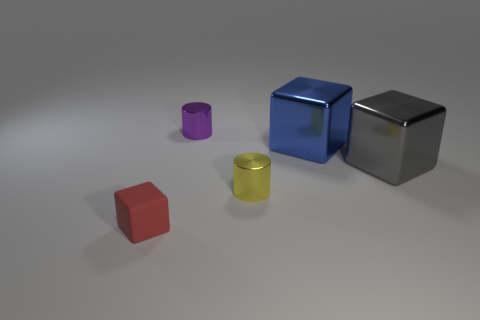Is there anything else that is the same size as the blue thing?
Ensure brevity in your answer.  Yes. What is the shape of the tiny metallic object that is in front of the gray shiny cube?
Provide a short and direct response. Cylinder. What is the color of the other small cylinder that is the same material as the purple cylinder?
Your response must be concise. Yellow. What material is the yellow thing that is the same shape as the purple shiny object?
Your response must be concise. Metal. What is the shape of the yellow metal object?
Keep it short and to the point. Cylinder. There is a small thing that is both in front of the big gray metal thing and on the right side of the small rubber block; what material is it?
Offer a very short reply. Metal. What is the shape of the big gray object that is made of the same material as the big blue thing?
Your answer should be compact. Cube. What size is the other block that is the same material as the gray block?
Your answer should be compact. Large. What is the shape of the metallic object that is both on the left side of the big blue cube and in front of the large blue block?
Provide a succinct answer. Cylinder. What is the size of the metallic object to the left of the small metallic thing that is on the right side of the purple metal thing?
Provide a succinct answer. Small. 